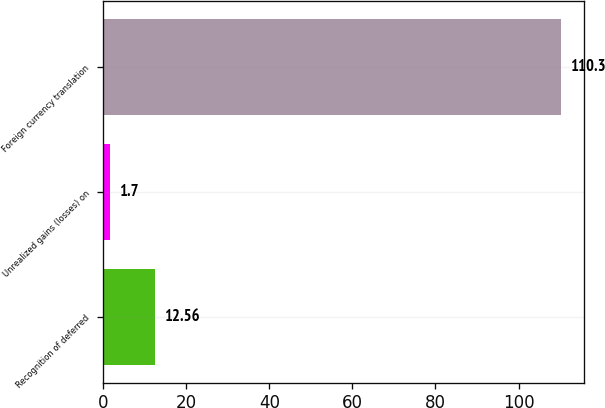Convert chart. <chart><loc_0><loc_0><loc_500><loc_500><bar_chart><fcel>Recognition of deferred<fcel>Unrealized gains (losses) on<fcel>Foreign currency translation<nl><fcel>12.56<fcel>1.7<fcel>110.3<nl></chart> 